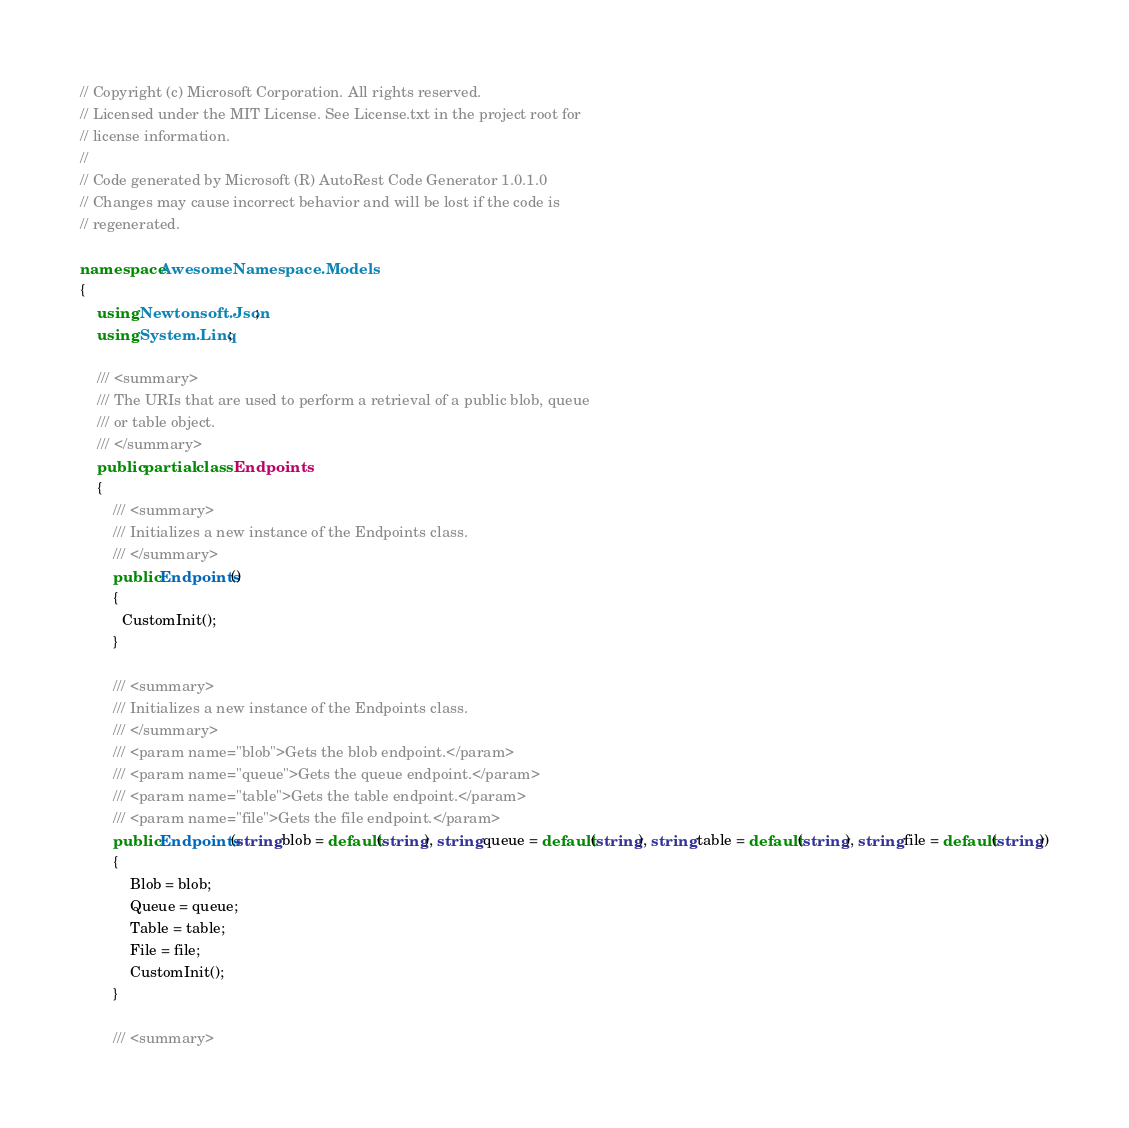Convert code to text. <code><loc_0><loc_0><loc_500><loc_500><_C#_>// Copyright (c) Microsoft Corporation. All rights reserved.
// Licensed under the MIT License. See License.txt in the project root for
// license information.
//
// Code generated by Microsoft (R) AutoRest Code Generator 1.0.1.0
// Changes may cause incorrect behavior and will be lost if the code is
// regenerated.

namespace AwesomeNamespace.Models
{
    using Newtonsoft.Json;
    using System.Linq;

    /// <summary>
    /// The URIs that are used to perform a retrieval of a public blob, queue
    /// or table object.
    /// </summary>
    public partial class Endpoints
    {
        /// <summary>
        /// Initializes a new instance of the Endpoints class.
        /// </summary>
        public Endpoints()
        {
          CustomInit();
        }

        /// <summary>
        /// Initializes a new instance of the Endpoints class.
        /// </summary>
        /// <param name="blob">Gets the blob endpoint.</param>
        /// <param name="queue">Gets the queue endpoint.</param>
        /// <param name="table">Gets the table endpoint.</param>
        /// <param name="file">Gets the file endpoint.</param>
        public Endpoints(string blob = default(string), string queue = default(string), string table = default(string), string file = default(string))
        {
            Blob = blob;
            Queue = queue;
            Table = table;
            File = file;
            CustomInit();
        }

        /// <summary></code> 